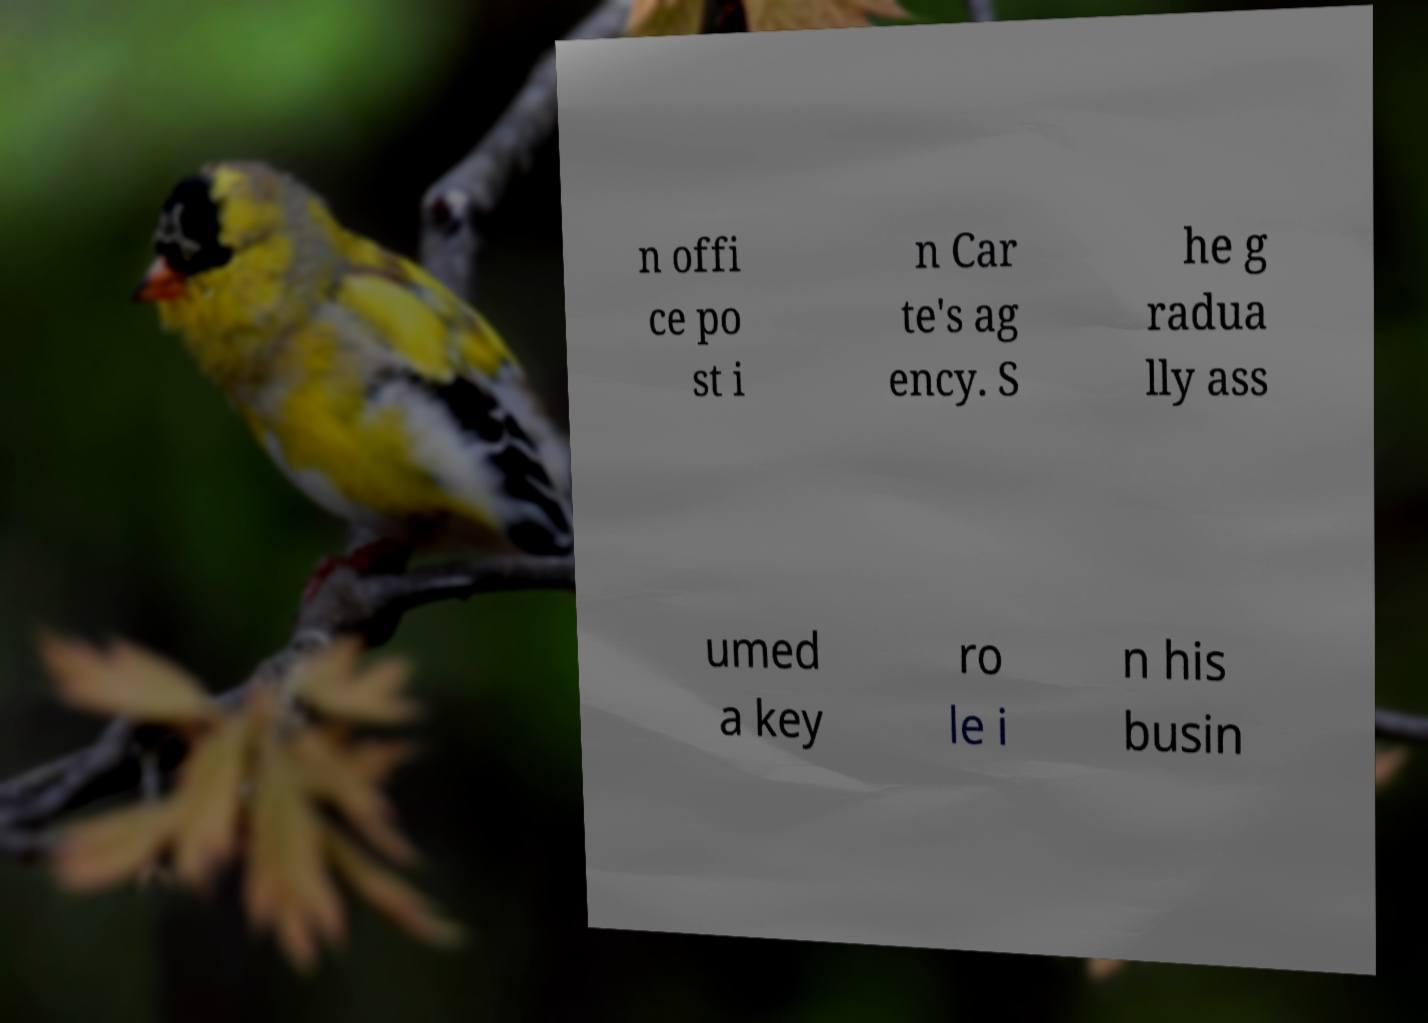Could you assist in decoding the text presented in this image and type it out clearly? n offi ce po st i n Car te's ag ency. S he g radua lly ass umed a key ro le i n his busin 